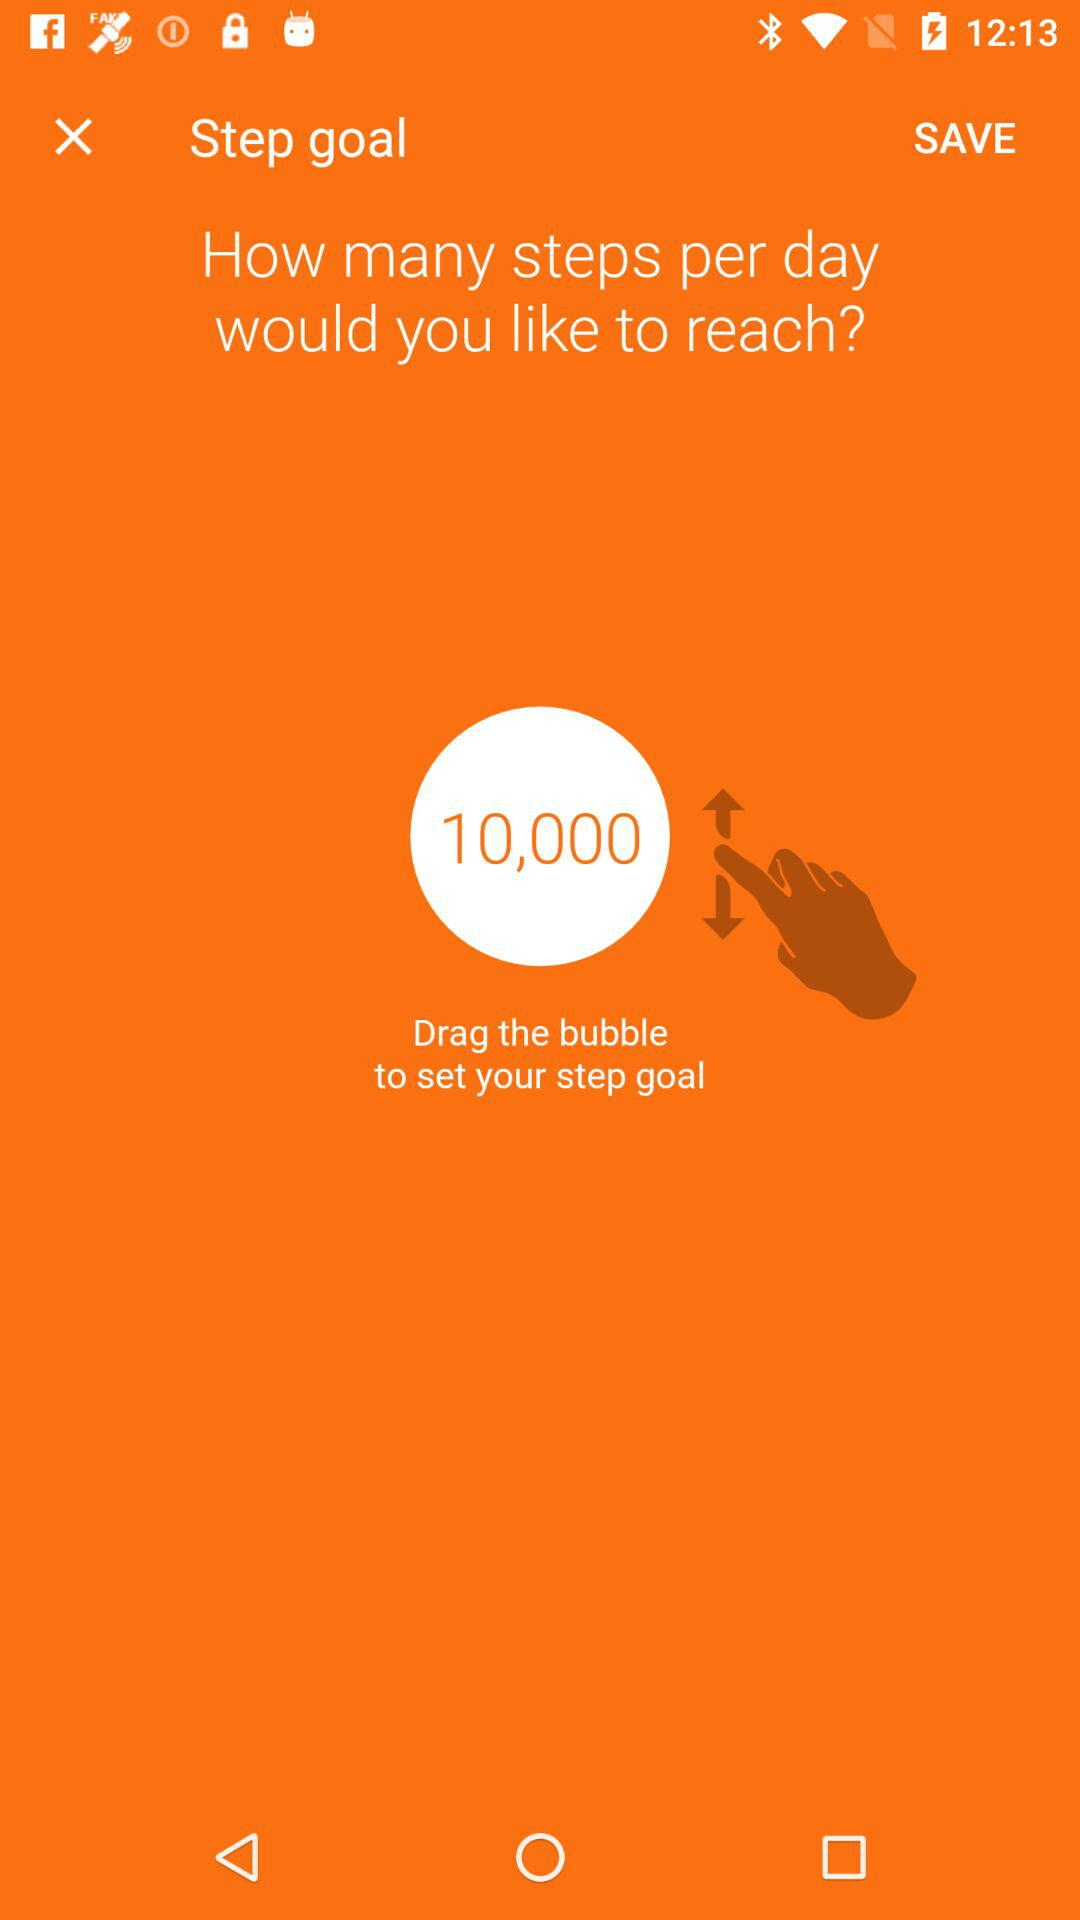How many steps per day is the user currently aiming for?
Answer the question using a single word or phrase. 10,000 